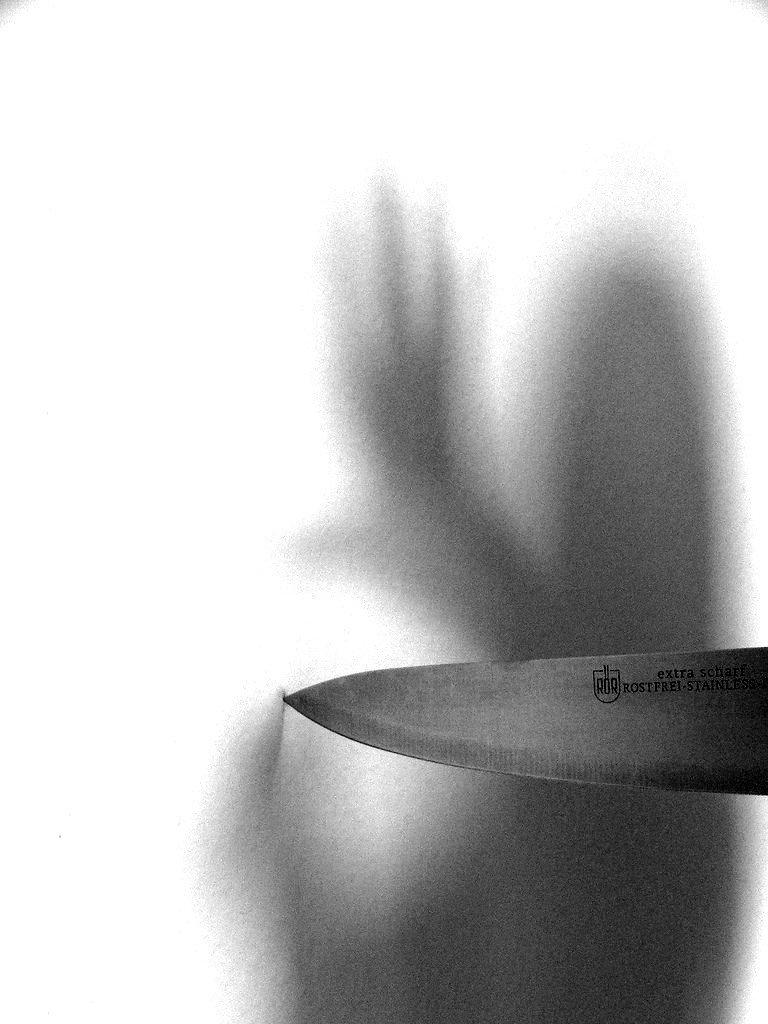What object can be seen in the image? There is a knife in the image. What else is visible in the image besides the knife? There is a shadow in the image. What type of brick is being used to create a shock in the office in the image? There is no brick, shock, or office present in the image; it only features a knife and a shadow. 